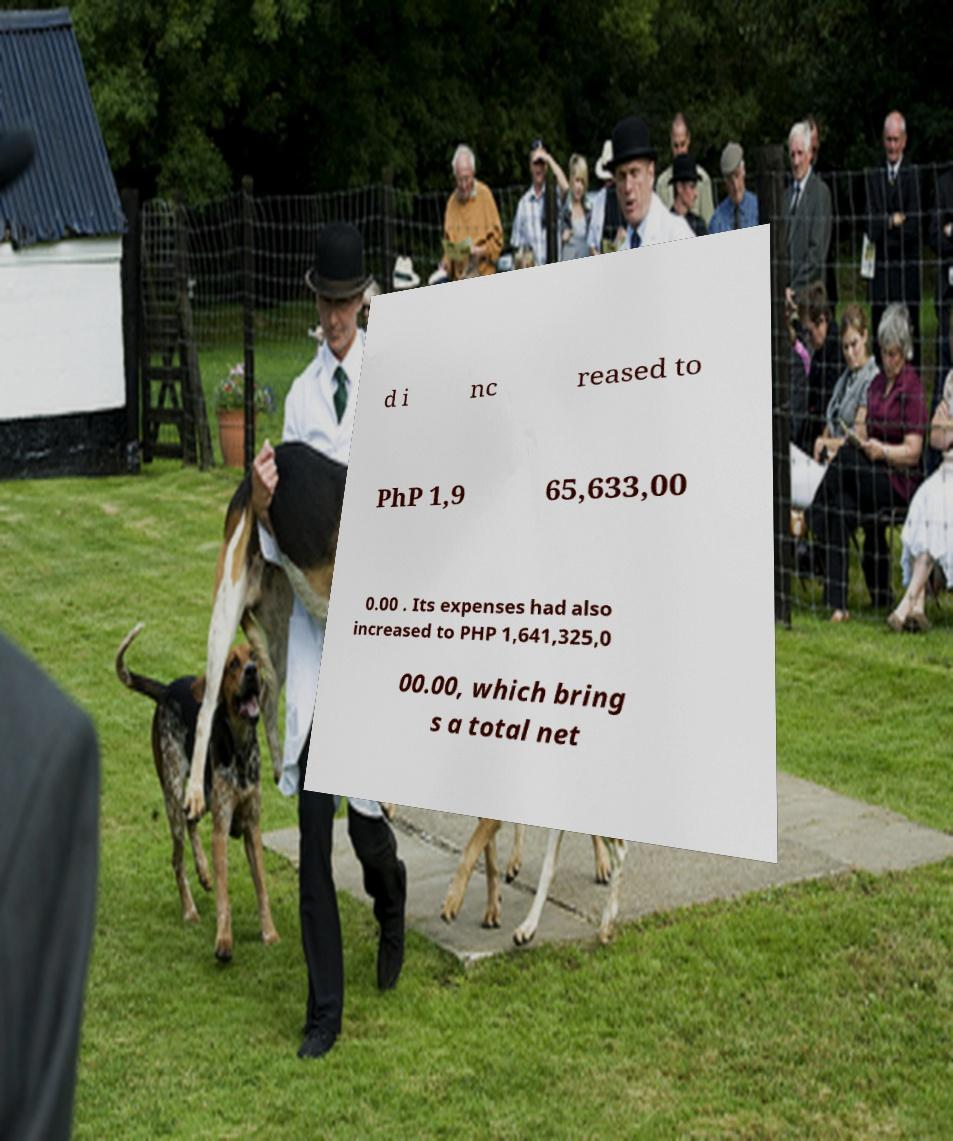What messages or text are displayed in this image? I need them in a readable, typed format. d i nc reased to PhP 1,9 65,633,00 0.00 . Its expenses had also increased to PHP 1,641,325,0 00.00, which bring s a total net 